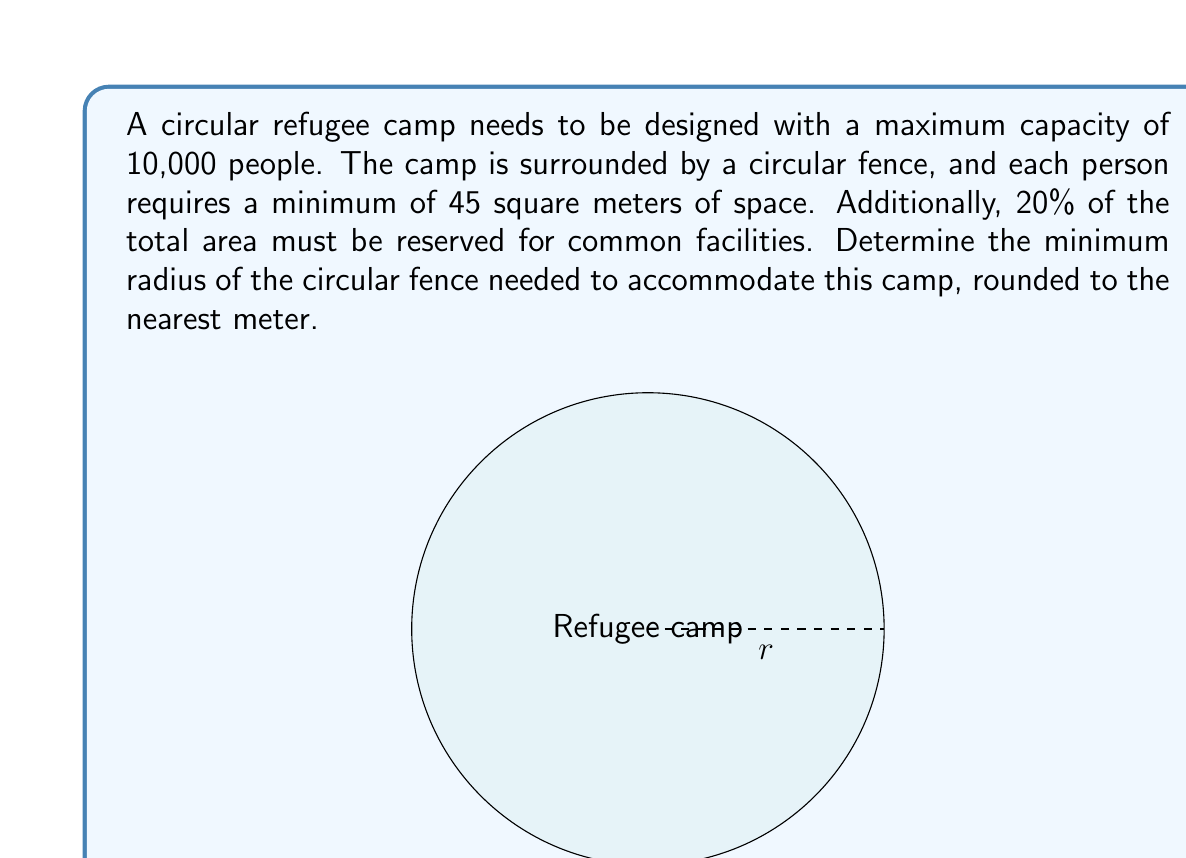Could you help me with this problem? Let's approach this step-by-step:

1) First, calculate the total area needed for people:
   $$A_{people} = 10,000 \text{ people} \times 45 \text{ m}^2/\text{person} = 450,000 \text{ m}^2$$

2) This represents 80% of the total area, as 20% is reserved for common facilities. To find the total area:
   $$A_{total} = \frac{A_{people}}{0.8} = \frac{450,000}{0.8} = 562,500 \text{ m}^2$$

3) Now, we need to find the radius of a circle with this area. The formula for the area of a circle is:
   $$A = \pi r^2$$

4) Rearranging this to solve for r:
   $$r = \sqrt{\frac{A}{\pi}}$$

5) Substituting our total area:
   $$r = \sqrt{\frac{562,500}{\pi}} \approx 422.635 \text{ m}$$

6) Rounding to the nearest meter:
   $$r \approx 423 \text{ m}$$

Therefore, the minimum radius of the circular fence needed is approximately 423 meters.
Answer: 423 m 